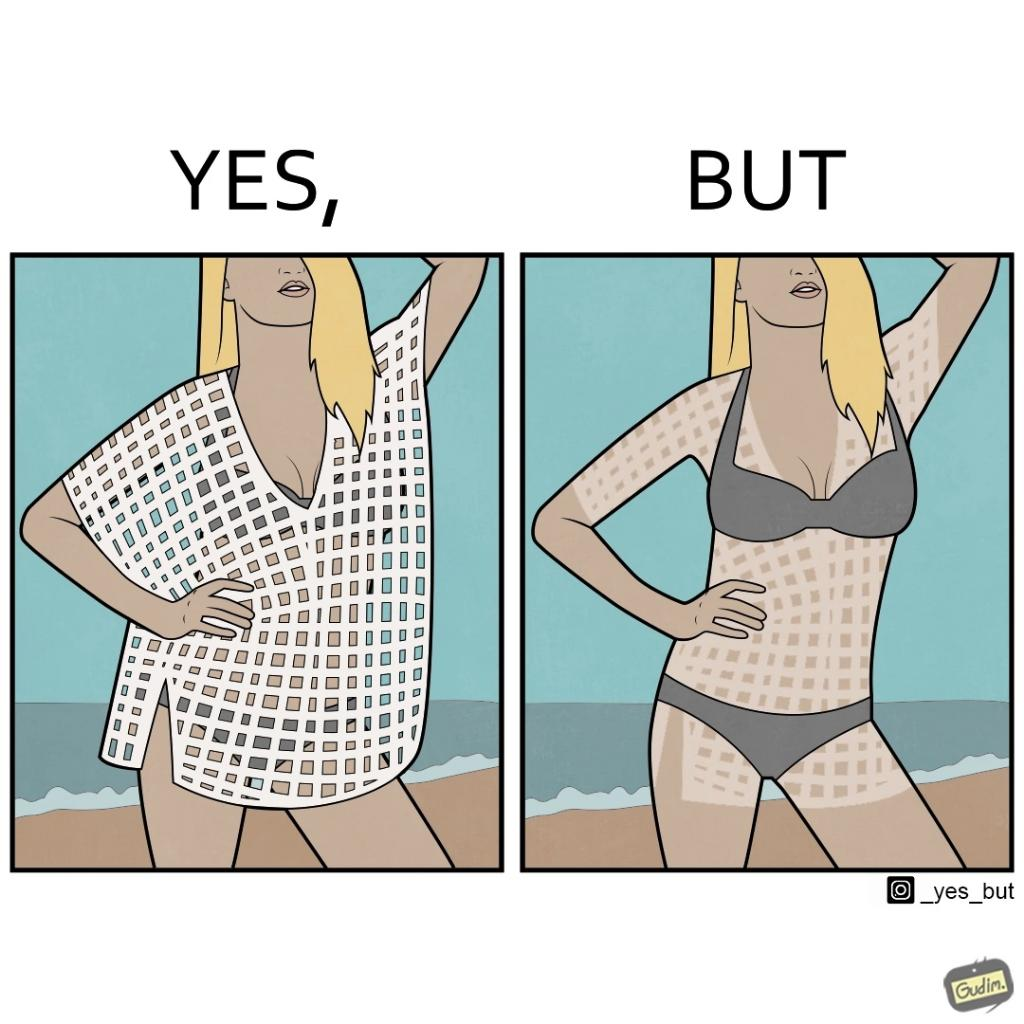Is this a satirical image? Yes, this image is satirical. 